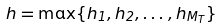Convert formula to latex. <formula><loc_0><loc_0><loc_500><loc_500>h = \max \{ h _ { 1 } , h _ { 2 } , \dots , h _ { M _ { T } } \}</formula> 